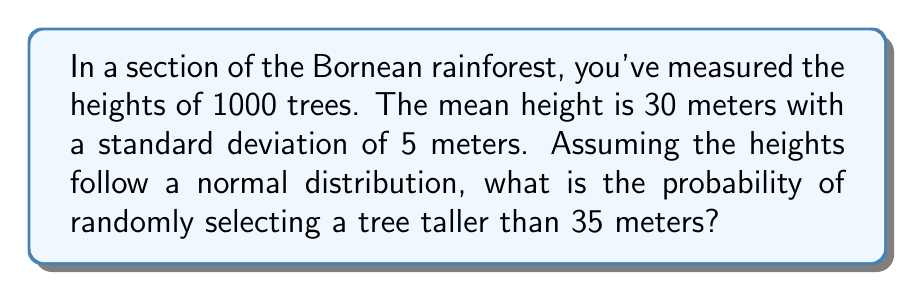Can you solve this math problem? To solve this problem, we'll use the properties of the normal distribution and the concept of z-scores.

Step 1: Identify the given information
- Mean height (μ) = 30 meters
- Standard deviation (σ) = 5 meters
- We want to find P(X > 35), where X is the height of a randomly selected tree

Step 2: Calculate the z-score for 35 meters
The z-score formula is: $z = \frac{x - \mu}{\sigma}$

Plugging in our values:
$z = \frac{35 - 30}{5} = 1$

Step 3: Use the standard normal distribution table or calculator
We need to find P(Z > 1), where Z is the standard normal random variable.

Using the symmetry of the normal distribution:
P(Z > 1) = 1 - P(Z < 1)

From a standard normal table or calculator:
P(Z < 1) ≈ 0.8413

Therefore:
P(Z > 1) = 1 - 0.8413 = 0.1587

Step 4: Interpret the result
The probability of randomly selecting a tree taller than 35 meters is approximately 0.1587 or 15.87%.
Answer: 0.1587 